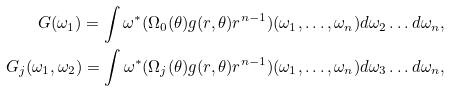<formula> <loc_0><loc_0><loc_500><loc_500>G ( \omega _ { 1 } ) = \int \omega ^ { * } ( \Omega _ { 0 } ( \theta ) g ( r , \theta ) r ^ { n - 1 } ) ( \omega _ { 1 } , \dots , \omega _ { n } ) d \omega _ { 2 } \dots d \omega _ { n } , \\ G _ { j } ( \omega _ { 1 } , \omega _ { 2 } ) = \int \omega ^ { * } ( \Omega _ { j } ( \theta ) g ( r , \theta ) r ^ { n - 1 } ) ( \omega _ { 1 } , \dots , \omega _ { n } ) d \omega _ { 3 } \dots d \omega _ { n } ,</formula> 